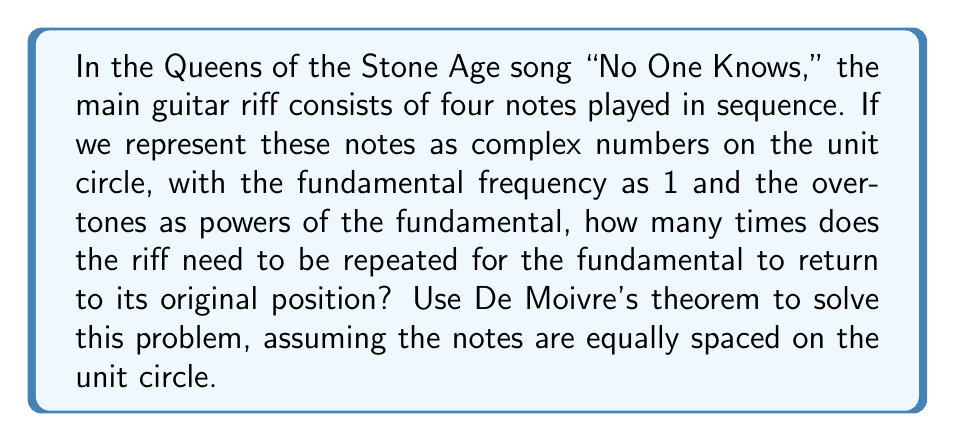Can you answer this question? Let's approach this step-by-step:

1) First, we represent the four notes as complex numbers on the unit circle. Since they are equally spaced, each note is rotated by $\frac{2\pi}{4} = \frac{\pi}{2}$ radians from the previous one.

2) We can represent these notes as:
   $$z_1 = e^{0i} = 1$$
   $$z_2 = e^{\frac{\pi}{2}i} = i$$
   $$z_3 = e^{\pi i} = -1$$
   $$z_4 = e^{\frac{3\pi}{2}i} = -i$$

3) Playing the riff once is equivalent to multiplying these complex numbers:
   $$z = z_1 \cdot z_2 \cdot z_3 \cdot z_4 = 1 \cdot i \cdot (-1) \cdot (-i) = 1$$

4) This means that after one repetition, we're back at the starting point. However, we need to consider the overtones as well.

5) Using De Moivre's theorem, we can represent the nth overtone of each note as:
   $$(z_k)^n = e^{\frac{(k-1)\pi n}{2}i}$$
   where $k$ is the note number (1 to 4) and $n$ is the overtone number.

6) For the riff to return to its original position for all overtones, we need:
   $$(z_1 \cdot z_2 \cdot z_3 \cdot z_4)^n = 1^n = 1$$

7) This is true for any integer $n$. However, for the individual notes to return to their original positions, we need:
   $$e^{\frac{(k-1)\pi n}{2}i} = 1$$
   for all $k$ from 1 to 4.

8) This is equivalent to:
   $$\frac{(k-1)\pi n}{2} = 2\pi m$$
   where $m$ is some integer.

9) The smallest positive $n$ that satisfies this for all $k$ is 4.
Answer: 4 repetitions 